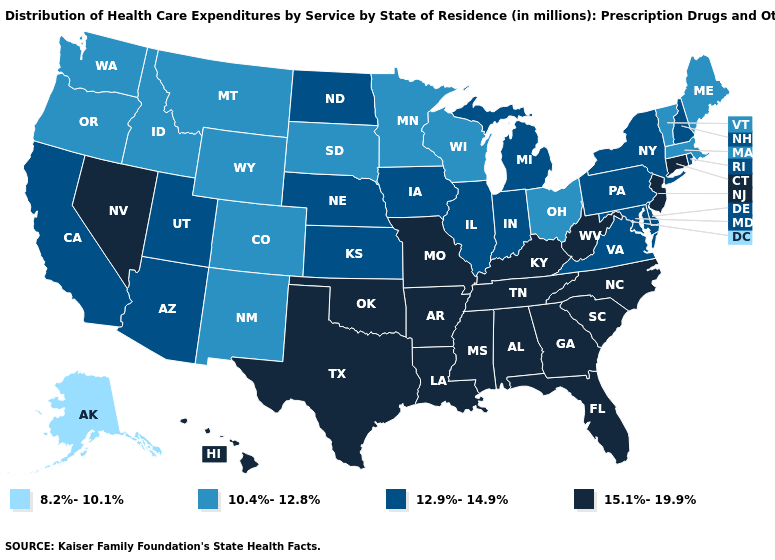What is the value of Maryland?
Quick response, please. 12.9%-14.9%. Does Tennessee have a lower value than Connecticut?
Answer briefly. No. What is the highest value in states that border Vermont?
Keep it brief. 12.9%-14.9%. Does Wisconsin have a higher value than Oregon?
Be succinct. No. Does the map have missing data?
Be succinct. No. Name the states that have a value in the range 12.9%-14.9%?
Answer briefly. Arizona, California, Delaware, Illinois, Indiana, Iowa, Kansas, Maryland, Michigan, Nebraska, New Hampshire, New York, North Dakota, Pennsylvania, Rhode Island, Utah, Virginia. What is the highest value in states that border Idaho?
Concise answer only. 15.1%-19.9%. Name the states that have a value in the range 15.1%-19.9%?
Quick response, please. Alabama, Arkansas, Connecticut, Florida, Georgia, Hawaii, Kentucky, Louisiana, Mississippi, Missouri, Nevada, New Jersey, North Carolina, Oklahoma, South Carolina, Tennessee, Texas, West Virginia. Does the map have missing data?
Quick response, please. No. Name the states that have a value in the range 15.1%-19.9%?
Keep it brief. Alabama, Arkansas, Connecticut, Florida, Georgia, Hawaii, Kentucky, Louisiana, Mississippi, Missouri, Nevada, New Jersey, North Carolina, Oklahoma, South Carolina, Tennessee, Texas, West Virginia. Name the states that have a value in the range 8.2%-10.1%?
Short answer required. Alaska. What is the value of Utah?
Be succinct. 12.9%-14.9%. Which states have the lowest value in the USA?
Give a very brief answer. Alaska. Among the states that border Arizona , which have the lowest value?
Answer briefly. Colorado, New Mexico. What is the value of Delaware?
Quick response, please. 12.9%-14.9%. 